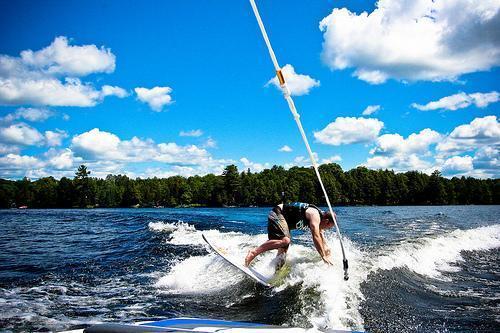How many people are in the photo?
Give a very brief answer. 1. 